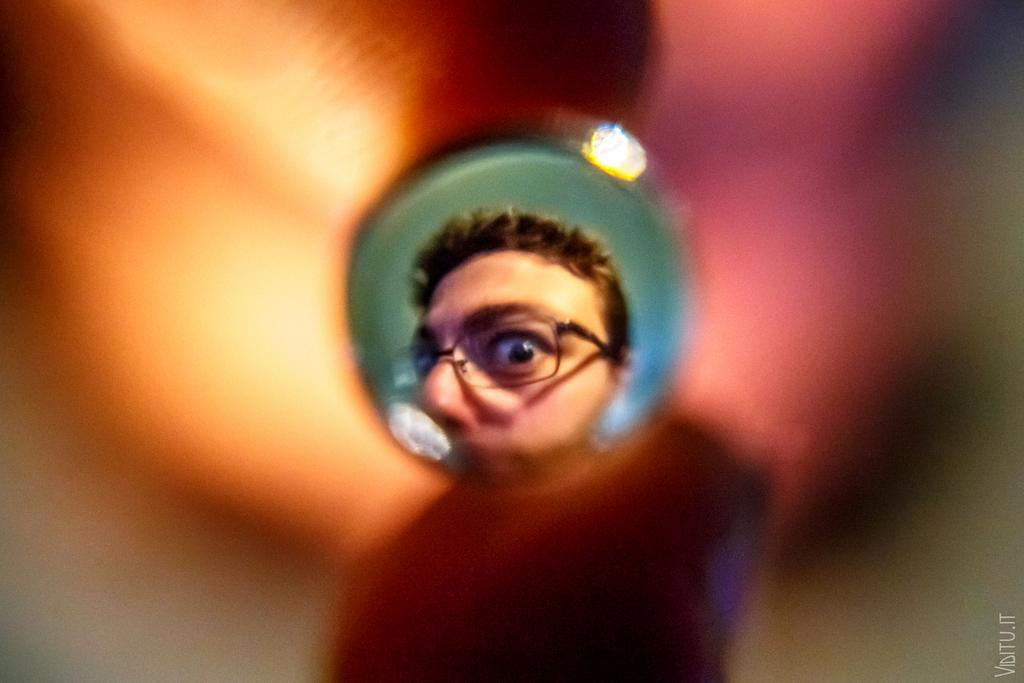Could you give a brief overview of what you see in this image? In the image we can see a person wearing spectacles, this is a watermark and this part of the image is blurred. 